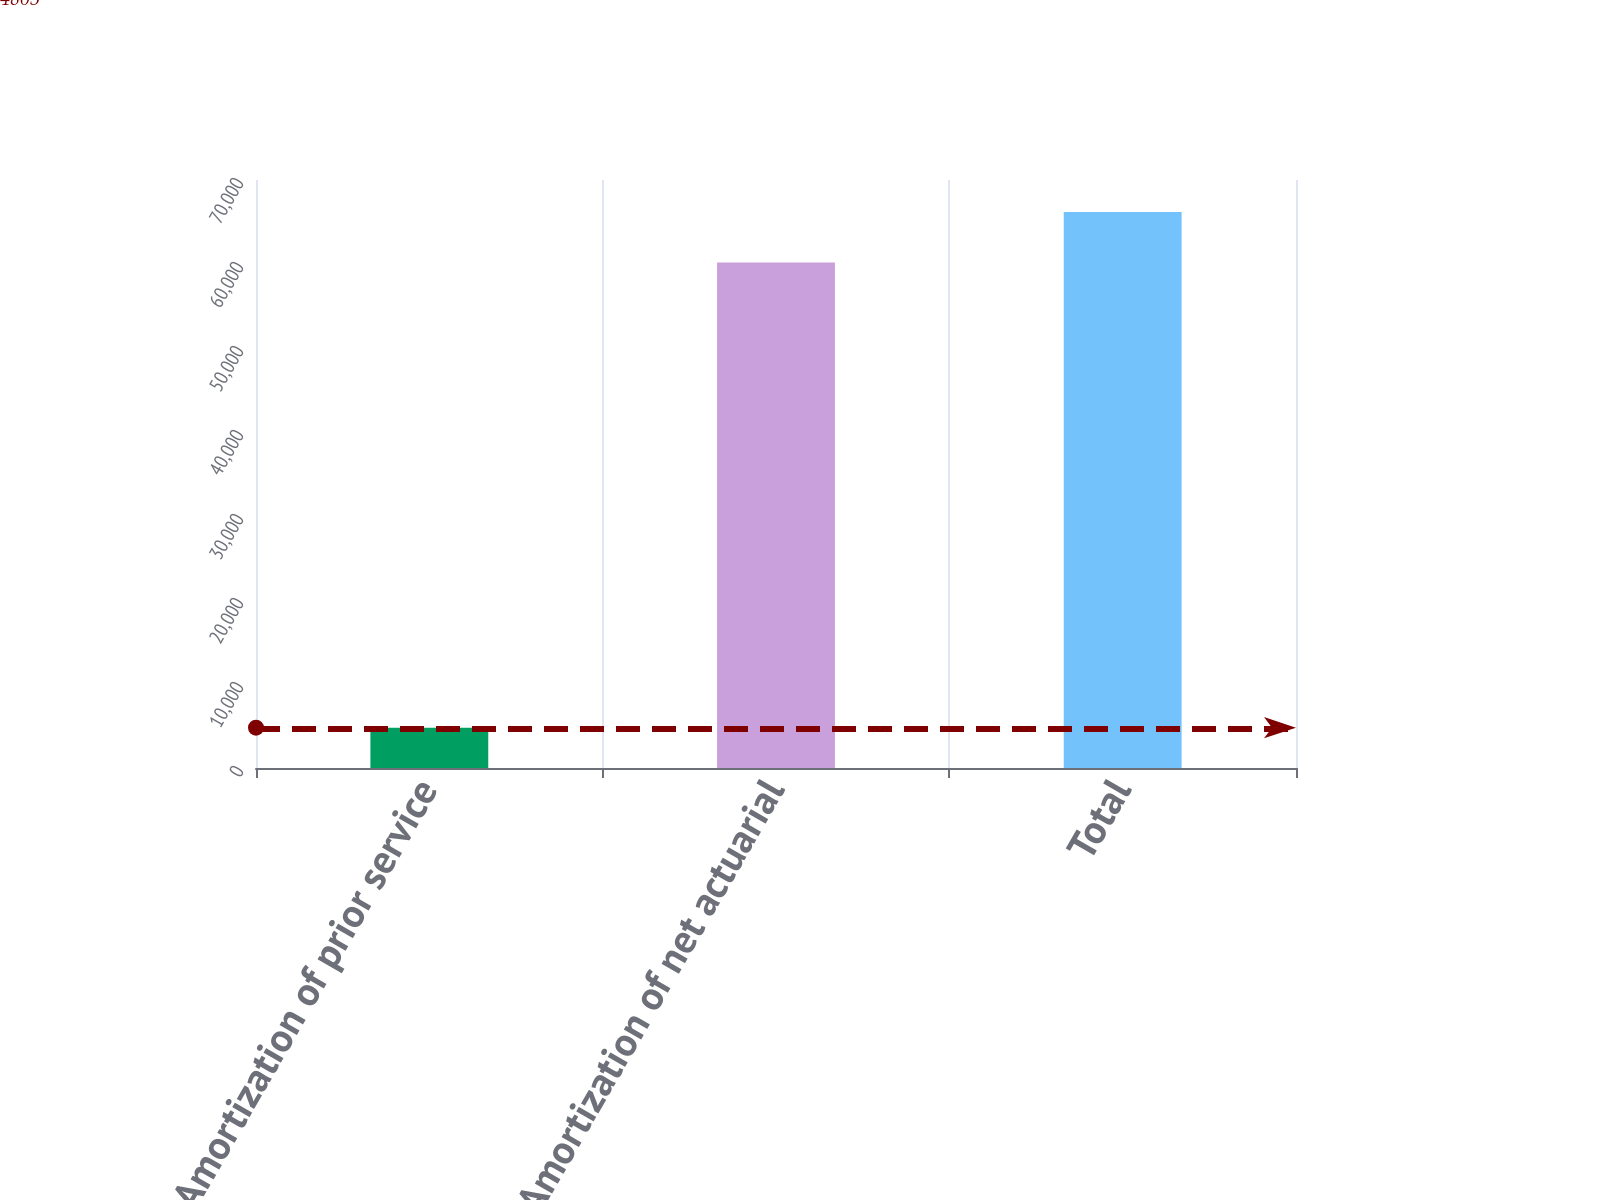<chart> <loc_0><loc_0><loc_500><loc_500><bar_chart><fcel>Amortization of prior service<fcel>Amortization of net actuarial<fcel>Total<nl><fcel>4805<fcel>60166<fcel>66182.6<nl></chart> 